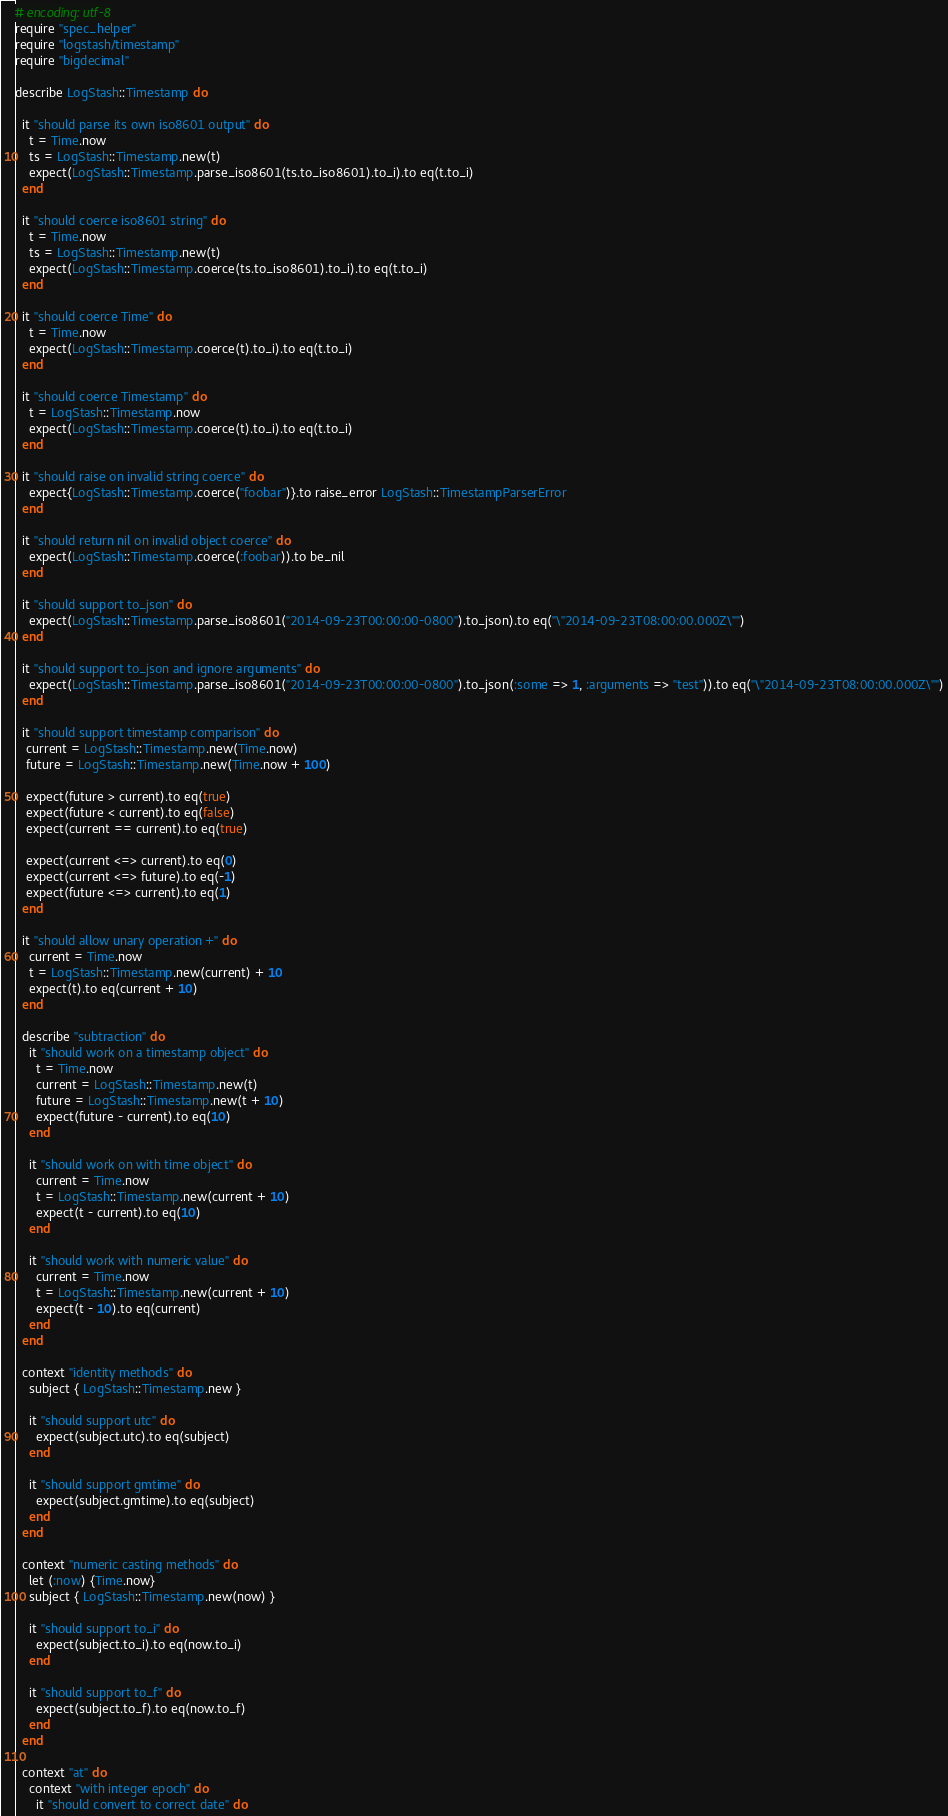Convert code to text. <code><loc_0><loc_0><loc_500><loc_500><_Ruby_># encoding: utf-8
require "spec_helper"
require "logstash/timestamp"
require "bigdecimal"

describe LogStash::Timestamp do

  it "should parse its own iso8601 output" do
    t = Time.now
    ts = LogStash::Timestamp.new(t)
    expect(LogStash::Timestamp.parse_iso8601(ts.to_iso8601).to_i).to eq(t.to_i)
  end

  it "should coerce iso8601 string" do
    t = Time.now
    ts = LogStash::Timestamp.new(t)
    expect(LogStash::Timestamp.coerce(ts.to_iso8601).to_i).to eq(t.to_i)
  end

  it "should coerce Time" do
    t = Time.now
    expect(LogStash::Timestamp.coerce(t).to_i).to eq(t.to_i)
  end

  it "should coerce Timestamp" do
    t = LogStash::Timestamp.now
    expect(LogStash::Timestamp.coerce(t).to_i).to eq(t.to_i)
  end

  it "should raise on invalid string coerce" do
    expect{LogStash::Timestamp.coerce("foobar")}.to raise_error LogStash::TimestampParserError
  end

  it "should return nil on invalid object coerce" do
    expect(LogStash::Timestamp.coerce(:foobar)).to be_nil
  end

  it "should support to_json" do
    expect(LogStash::Timestamp.parse_iso8601("2014-09-23T00:00:00-0800").to_json).to eq("\"2014-09-23T08:00:00.000Z\"")
  end

  it "should support to_json and ignore arguments" do
    expect(LogStash::Timestamp.parse_iso8601("2014-09-23T00:00:00-0800").to_json(:some => 1, :arguments => "test")).to eq("\"2014-09-23T08:00:00.000Z\"")
  end

  it "should support timestamp comparison" do
   current = LogStash::Timestamp.new(Time.now) 
   future = LogStash::Timestamp.new(Time.now + 100)

   expect(future > current).to eq(true)
   expect(future < current).to eq(false)
   expect(current == current).to eq(true)

   expect(current <=> current).to eq(0)
   expect(current <=> future).to eq(-1)
   expect(future <=> current).to eq(1)
  end

  it "should allow unary operation +" do
    current = Time.now
    t = LogStash::Timestamp.new(current) + 10
    expect(t).to eq(current + 10)
  end

  describe "subtraction" do
    it "should work on a timestamp object" do
      t = Time.now
      current = LogStash::Timestamp.new(t)
      future = LogStash::Timestamp.new(t + 10)
      expect(future - current).to eq(10)
    end

    it "should work on with time object" do
      current = Time.now
      t = LogStash::Timestamp.new(current + 10)
      expect(t - current).to eq(10)
    end

    it "should work with numeric value" do
      current = Time.now
      t = LogStash::Timestamp.new(current + 10)
      expect(t - 10).to eq(current)
    end
  end

  context "identity methods" do
    subject { LogStash::Timestamp.new }

    it "should support utc" do
      expect(subject.utc).to eq(subject)
    end

    it "should support gmtime" do
      expect(subject.gmtime).to eq(subject)
    end
  end

  context "numeric casting methods" do
    let (:now) {Time.now}
    subject { LogStash::Timestamp.new(now) }

    it "should support to_i" do
      expect(subject.to_i).to eq(now.to_i)
    end

    it "should support to_f" do
      expect(subject.to_f).to eq(now.to_f)
    end
  end

  context "at" do
    context "with integer epoch" do
      it "should convert to correct date" do</code> 